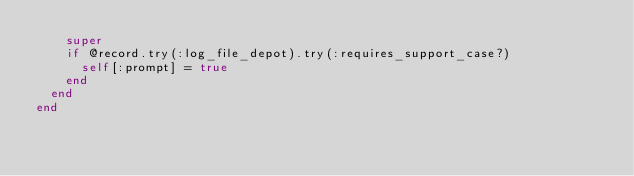Convert code to text. <code><loc_0><loc_0><loc_500><loc_500><_Ruby_>    super
    if @record.try(:log_file_depot).try(:requires_support_case?)
      self[:prompt] = true
    end
  end
end
</code> 